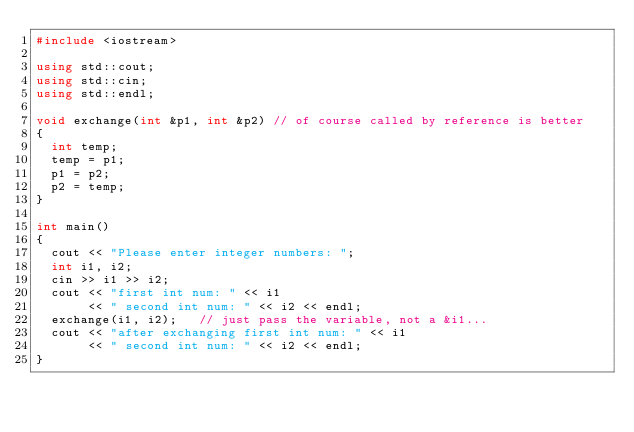<code> <loc_0><loc_0><loc_500><loc_500><_C++_>#include <iostream>

using std::cout;
using std::cin;
using std::endl;

void exchange(int &p1, int &p2)	// of course called by reference is better
{
  int temp;
  temp = p1;
  p1 = p2;
  p2 = temp;
}

int main()
{
  cout << "Please enter integer numbers: ";
  int i1, i2;
  cin >> i1 >> i2;
  cout << "first int num: " << i1
       << " second int num: " << i2 << endl;
  exchange(i1, i2);		// just pass the variable, not a &i1...
  cout << "after exchanging first int num: " << i1
       << " second int num: " << i2 << endl;
}

</code> 